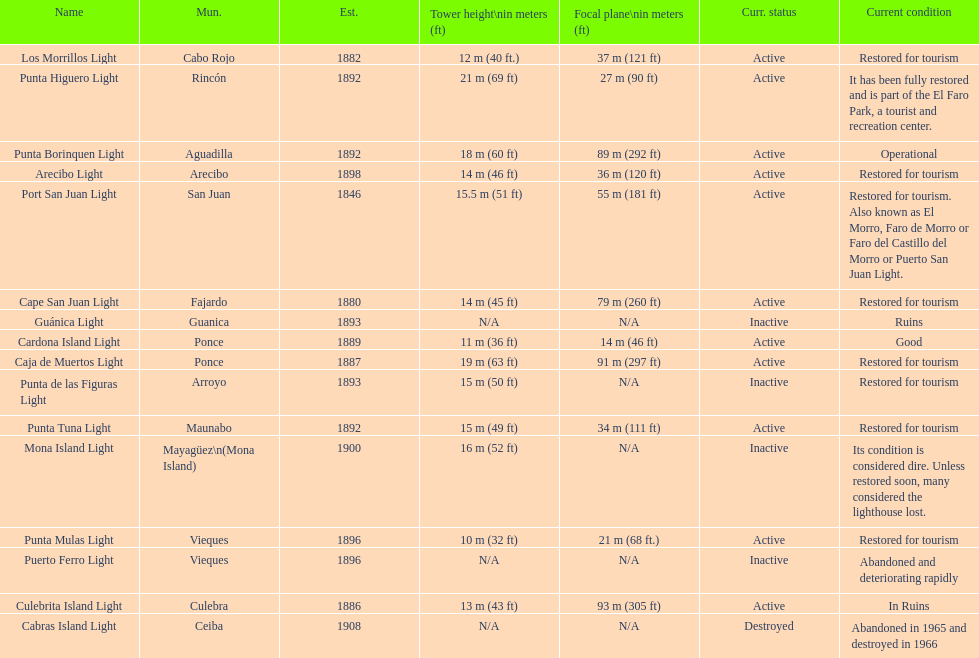Names of municipalities established before 1880 San Juan. Would you mind parsing the complete table? {'header': ['Name', 'Mun.', 'Est.', 'Tower height\\nin meters (ft)', 'Focal plane\\nin meters (ft)', 'Curr. status', 'Current condition'], 'rows': [['Los Morrillos Light', 'Cabo Rojo', '1882', '12\xa0m (40\xa0ft.)', '37\xa0m (121\xa0ft)', 'Active', 'Restored for tourism'], ['Punta Higuero Light', 'Rincón', '1892', '21\xa0m (69\xa0ft)', '27\xa0m (90\xa0ft)', 'Active', 'It has been fully restored and is part of the El Faro Park, a tourist and recreation center.'], ['Punta Borinquen Light', 'Aguadilla', '1892', '18\xa0m (60\xa0ft)', '89\xa0m (292\xa0ft)', 'Active', 'Operational'], ['Arecibo Light', 'Arecibo', '1898', '14\xa0m (46\xa0ft)', '36\xa0m (120\xa0ft)', 'Active', 'Restored for tourism'], ['Port San Juan Light', 'San Juan', '1846', '15.5\xa0m (51\xa0ft)', '55\xa0m (181\xa0ft)', 'Active', 'Restored for tourism. Also known as El Morro, Faro de Morro or Faro del Castillo del Morro or Puerto San Juan Light.'], ['Cape San Juan Light', 'Fajardo', '1880', '14\xa0m (45\xa0ft)', '79\xa0m (260\xa0ft)', 'Active', 'Restored for tourism'], ['Guánica Light', 'Guanica', '1893', 'N/A', 'N/A', 'Inactive', 'Ruins'], ['Cardona Island Light', 'Ponce', '1889', '11\xa0m (36\xa0ft)', '14\xa0m (46\xa0ft)', 'Active', 'Good'], ['Caja de Muertos Light', 'Ponce', '1887', '19\xa0m (63\xa0ft)', '91\xa0m (297\xa0ft)', 'Active', 'Restored for tourism'], ['Punta de las Figuras Light', 'Arroyo', '1893', '15\xa0m (50\xa0ft)', 'N/A', 'Inactive', 'Restored for tourism'], ['Punta Tuna Light', 'Maunabo', '1892', '15\xa0m (49\xa0ft)', '34\xa0m (111\xa0ft)', 'Active', 'Restored for tourism'], ['Mona Island Light', 'Mayagüez\\n(Mona Island)', '1900', '16\xa0m (52\xa0ft)', 'N/A', 'Inactive', 'Its condition is considered dire. Unless restored soon, many considered the lighthouse lost.'], ['Punta Mulas Light', 'Vieques', '1896', '10\xa0m (32\xa0ft)', '21\xa0m (68\xa0ft.)', 'Active', 'Restored for tourism'], ['Puerto Ferro Light', 'Vieques', '1896', 'N/A', 'N/A', 'Inactive', 'Abandoned and deteriorating rapidly'], ['Culebrita Island Light', 'Culebra', '1886', '13\xa0m (43\xa0ft)', '93\xa0m (305\xa0ft)', 'Active', 'In Ruins'], ['Cabras Island Light', 'Ceiba', '1908', 'N/A', 'N/A', 'Destroyed', 'Abandoned in 1965 and destroyed in 1966']]} 